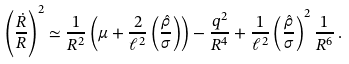<formula> <loc_0><loc_0><loc_500><loc_500>\left ( \frac { \dot { R } } { R } \right ) ^ { 2 } \simeq \frac { 1 } { R ^ { 2 } } \left ( \mu + \frac { 2 } { \ell ^ { 2 } } \left ( \frac { \hat { \rho } } { \sigma } \right ) \right ) - \frac { q ^ { 2 } } { R ^ { 4 } } + \frac { 1 } { \ell ^ { 2 } } \left ( \frac { \hat { \rho } } { \sigma } \right ) ^ { 2 } \frac { 1 } { R ^ { 6 } } \, .</formula> 